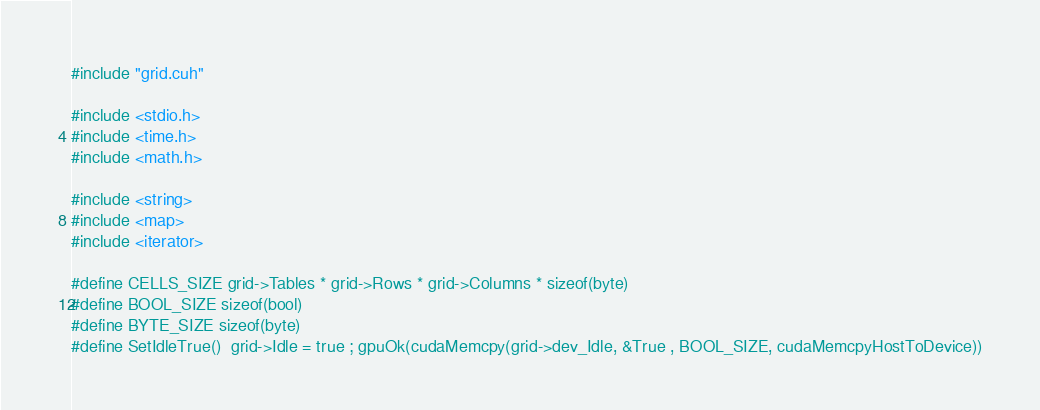Convert code to text. <code><loc_0><loc_0><loc_500><loc_500><_Cuda_>#include "grid.cuh"

#include <stdio.h>
#include <time.h>
#include <math.h>

#include <string>
#include <map>
#include <iterator>

#define CELLS_SIZE grid->Tables * grid->Rows * grid->Columns * sizeof(byte)
#define BOOL_SIZE sizeof(bool)
#define BYTE_SIZE sizeof(byte)
#define SetIdleTrue()  grid->Idle = true ; gpuOk(cudaMemcpy(grid->dev_Idle, &True , BOOL_SIZE, cudaMemcpyHostToDevice))</code> 